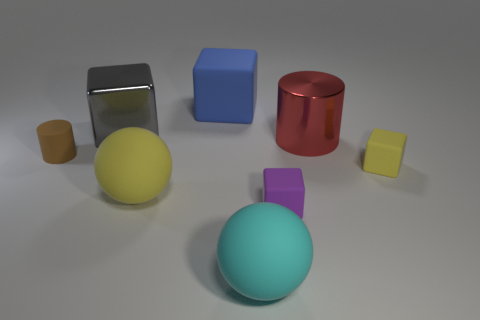What shape is the big red thing that is behind the tiny thing that is left of the blue matte object?
Keep it short and to the point. Cylinder. There is a big red thing; does it have the same shape as the rubber object that is on the right side of the purple block?
Give a very brief answer. No. The metallic cylinder that is the same size as the blue block is what color?
Make the answer very short. Red. Are there fewer metal blocks on the right side of the yellow ball than large metallic blocks behind the large cyan ball?
Provide a short and direct response. Yes. There is a big matte thing on the left side of the matte object behind the rubber thing that is to the left of the metal block; what shape is it?
Keep it short and to the point. Sphere. There is a small cube behind the big yellow thing; is it the same color as the ball on the left side of the cyan ball?
Ensure brevity in your answer.  Yes. How many rubber things are either brown objects or small purple things?
Ensure brevity in your answer.  2. There is a small block that is left of the yellow rubber thing that is on the right side of the yellow rubber thing left of the tiny yellow block; what is its color?
Give a very brief answer. Purple. What color is the other tiny rubber thing that is the same shape as the tiny purple thing?
Keep it short and to the point. Yellow. Is there any other thing that has the same color as the big matte cube?
Keep it short and to the point. No. 